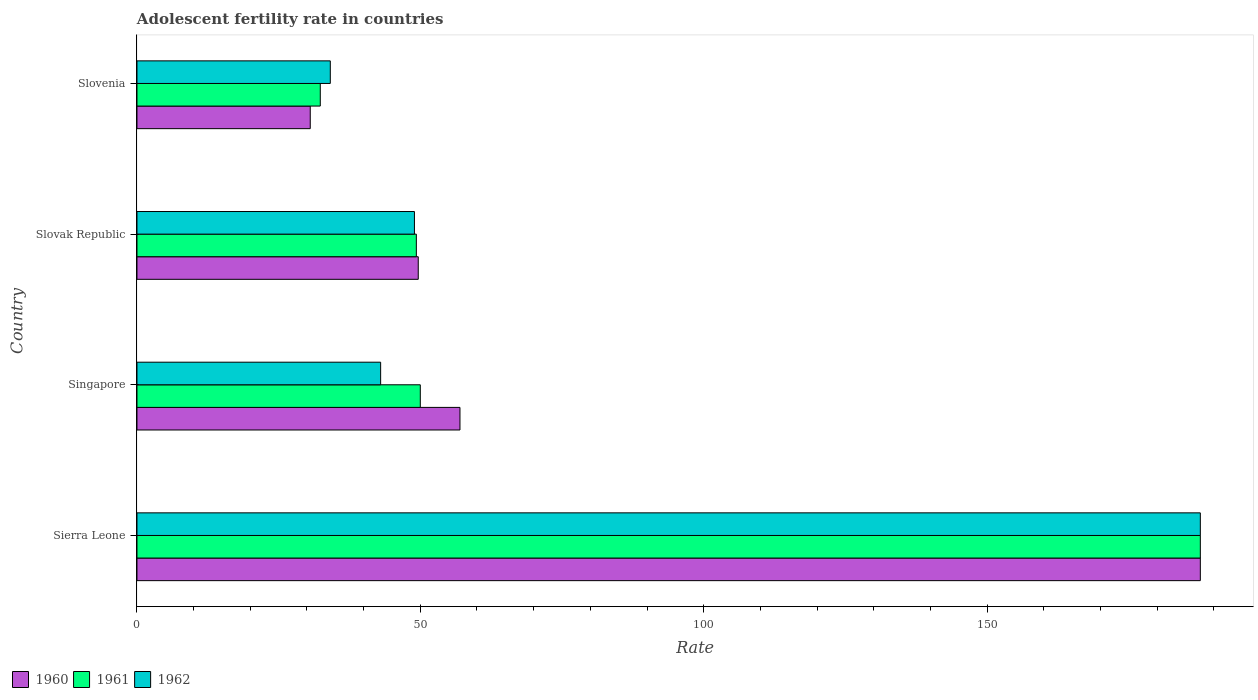How many different coloured bars are there?
Keep it short and to the point. 3. How many groups of bars are there?
Offer a terse response. 4. Are the number of bars per tick equal to the number of legend labels?
Offer a very short reply. Yes. Are the number of bars on each tick of the Y-axis equal?
Your response must be concise. Yes. How many bars are there on the 2nd tick from the top?
Provide a short and direct response. 3. How many bars are there on the 3rd tick from the bottom?
Your response must be concise. 3. What is the label of the 1st group of bars from the top?
Your answer should be compact. Slovenia. In how many cases, is the number of bars for a given country not equal to the number of legend labels?
Your response must be concise. 0. What is the adolescent fertility rate in 1962 in Slovak Republic?
Make the answer very short. 48.96. Across all countries, what is the maximum adolescent fertility rate in 1961?
Make the answer very short. 187.64. Across all countries, what is the minimum adolescent fertility rate in 1961?
Keep it short and to the point. 32.35. In which country was the adolescent fertility rate in 1962 maximum?
Offer a very short reply. Sierra Leone. In which country was the adolescent fertility rate in 1961 minimum?
Provide a short and direct response. Slovenia. What is the total adolescent fertility rate in 1961 in the graph?
Provide a short and direct response. 319.28. What is the difference between the adolescent fertility rate in 1960 in Sierra Leone and that in Slovak Republic?
Provide a short and direct response. 138. What is the difference between the adolescent fertility rate in 1962 in Slovak Republic and the adolescent fertility rate in 1960 in Slovenia?
Offer a very short reply. 18.38. What is the average adolescent fertility rate in 1960 per country?
Keep it short and to the point. 81.21. What is the difference between the adolescent fertility rate in 1962 and adolescent fertility rate in 1960 in Slovenia?
Give a very brief answer. 3.54. In how many countries, is the adolescent fertility rate in 1962 greater than 50 ?
Your answer should be very brief. 1. What is the ratio of the adolescent fertility rate in 1962 in Singapore to that in Slovak Republic?
Make the answer very short. 0.88. Is the adolescent fertility rate in 1961 in Slovak Republic less than that in Slovenia?
Offer a very short reply. No. What is the difference between the highest and the second highest adolescent fertility rate in 1960?
Give a very brief answer. 130.64. What is the difference between the highest and the lowest adolescent fertility rate in 1961?
Offer a very short reply. 155.29. Is the sum of the adolescent fertility rate in 1962 in Singapore and Slovenia greater than the maximum adolescent fertility rate in 1961 across all countries?
Your answer should be compact. No. What does the 3rd bar from the bottom in Slovenia represents?
Make the answer very short. 1962. How many countries are there in the graph?
Ensure brevity in your answer.  4. Are the values on the major ticks of X-axis written in scientific E-notation?
Keep it short and to the point. No. Does the graph contain grids?
Your answer should be very brief. No. Where does the legend appear in the graph?
Your answer should be very brief. Bottom left. What is the title of the graph?
Ensure brevity in your answer.  Adolescent fertility rate in countries. What is the label or title of the X-axis?
Your response must be concise. Rate. What is the label or title of the Y-axis?
Make the answer very short. Country. What is the Rate of 1960 in Sierra Leone?
Your answer should be very brief. 187.64. What is the Rate of 1961 in Sierra Leone?
Give a very brief answer. 187.64. What is the Rate of 1962 in Sierra Leone?
Keep it short and to the point. 187.64. What is the Rate in 1960 in Singapore?
Ensure brevity in your answer.  57. What is the Rate in 1961 in Singapore?
Give a very brief answer. 50. What is the Rate in 1962 in Singapore?
Your answer should be very brief. 43. What is the Rate of 1960 in Slovak Republic?
Ensure brevity in your answer.  49.64. What is the Rate in 1961 in Slovak Republic?
Offer a terse response. 49.3. What is the Rate of 1962 in Slovak Republic?
Offer a terse response. 48.96. What is the Rate of 1960 in Slovenia?
Make the answer very short. 30.58. What is the Rate of 1961 in Slovenia?
Offer a terse response. 32.35. What is the Rate in 1962 in Slovenia?
Provide a succinct answer. 34.12. Across all countries, what is the maximum Rate in 1960?
Make the answer very short. 187.64. Across all countries, what is the maximum Rate of 1961?
Make the answer very short. 187.64. Across all countries, what is the maximum Rate of 1962?
Make the answer very short. 187.64. Across all countries, what is the minimum Rate of 1960?
Offer a terse response. 30.58. Across all countries, what is the minimum Rate of 1961?
Provide a succinct answer. 32.35. Across all countries, what is the minimum Rate of 1962?
Offer a very short reply. 34.12. What is the total Rate in 1960 in the graph?
Offer a terse response. 324.85. What is the total Rate of 1961 in the graph?
Offer a terse response. 319.28. What is the total Rate of 1962 in the graph?
Keep it short and to the point. 313.72. What is the difference between the Rate in 1960 in Sierra Leone and that in Singapore?
Provide a short and direct response. 130.64. What is the difference between the Rate of 1961 in Sierra Leone and that in Singapore?
Keep it short and to the point. 137.64. What is the difference between the Rate of 1962 in Sierra Leone and that in Singapore?
Keep it short and to the point. 144.64. What is the difference between the Rate in 1960 in Sierra Leone and that in Slovak Republic?
Offer a terse response. 138. What is the difference between the Rate in 1961 in Sierra Leone and that in Slovak Republic?
Offer a terse response. 138.34. What is the difference between the Rate in 1962 in Sierra Leone and that in Slovak Republic?
Your response must be concise. 138.68. What is the difference between the Rate of 1960 in Sierra Leone and that in Slovenia?
Provide a short and direct response. 157.06. What is the difference between the Rate of 1961 in Sierra Leone and that in Slovenia?
Ensure brevity in your answer.  155.29. What is the difference between the Rate in 1962 in Sierra Leone and that in Slovenia?
Keep it short and to the point. 153.52. What is the difference between the Rate of 1960 in Singapore and that in Slovak Republic?
Your answer should be compact. 7.36. What is the difference between the Rate of 1961 in Singapore and that in Slovak Republic?
Offer a very short reply. 0.7. What is the difference between the Rate in 1962 in Singapore and that in Slovak Republic?
Your answer should be compact. -5.96. What is the difference between the Rate of 1960 in Singapore and that in Slovenia?
Provide a short and direct response. 26.42. What is the difference between the Rate in 1961 in Singapore and that in Slovenia?
Provide a succinct answer. 17.65. What is the difference between the Rate in 1962 in Singapore and that in Slovenia?
Give a very brief answer. 8.88. What is the difference between the Rate of 1960 in Slovak Republic and that in Slovenia?
Make the answer very short. 19.06. What is the difference between the Rate of 1961 in Slovak Republic and that in Slovenia?
Offer a terse response. 16.95. What is the difference between the Rate of 1962 in Slovak Republic and that in Slovenia?
Your answer should be compact. 14.85. What is the difference between the Rate in 1960 in Sierra Leone and the Rate in 1961 in Singapore?
Your answer should be compact. 137.64. What is the difference between the Rate of 1960 in Sierra Leone and the Rate of 1962 in Singapore?
Provide a succinct answer. 144.64. What is the difference between the Rate of 1961 in Sierra Leone and the Rate of 1962 in Singapore?
Your response must be concise. 144.64. What is the difference between the Rate in 1960 in Sierra Leone and the Rate in 1961 in Slovak Republic?
Keep it short and to the point. 138.34. What is the difference between the Rate in 1960 in Sierra Leone and the Rate in 1962 in Slovak Republic?
Offer a terse response. 138.68. What is the difference between the Rate of 1961 in Sierra Leone and the Rate of 1962 in Slovak Republic?
Ensure brevity in your answer.  138.68. What is the difference between the Rate in 1960 in Sierra Leone and the Rate in 1961 in Slovenia?
Keep it short and to the point. 155.29. What is the difference between the Rate in 1960 in Sierra Leone and the Rate in 1962 in Slovenia?
Provide a succinct answer. 153.52. What is the difference between the Rate of 1961 in Sierra Leone and the Rate of 1962 in Slovenia?
Make the answer very short. 153.52. What is the difference between the Rate of 1960 in Singapore and the Rate of 1961 in Slovak Republic?
Your answer should be compact. 7.7. What is the difference between the Rate in 1960 in Singapore and the Rate in 1962 in Slovak Republic?
Give a very brief answer. 8.03. What is the difference between the Rate of 1961 in Singapore and the Rate of 1962 in Slovak Republic?
Your answer should be compact. 1.03. What is the difference between the Rate in 1960 in Singapore and the Rate in 1961 in Slovenia?
Your answer should be compact. 24.65. What is the difference between the Rate of 1960 in Singapore and the Rate of 1962 in Slovenia?
Give a very brief answer. 22.88. What is the difference between the Rate of 1961 in Singapore and the Rate of 1962 in Slovenia?
Your response must be concise. 15.88. What is the difference between the Rate in 1960 in Slovak Republic and the Rate in 1961 in Slovenia?
Offer a terse response. 17.29. What is the difference between the Rate of 1960 in Slovak Republic and the Rate of 1962 in Slovenia?
Keep it short and to the point. 15.52. What is the difference between the Rate of 1961 in Slovak Republic and the Rate of 1962 in Slovenia?
Offer a very short reply. 15.18. What is the average Rate of 1960 per country?
Make the answer very short. 81.21. What is the average Rate in 1961 per country?
Give a very brief answer. 79.82. What is the average Rate in 1962 per country?
Offer a very short reply. 78.43. What is the difference between the Rate of 1960 and Rate of 1962 in Sierra Leone?
Provide a succinct answer. 0. What is the difference between the Rate of 1961 and Rate of 1962 in Sierra Leone?
Offer a very short reply. 0. What is the difference between the Rate in 1960 and Rate in 1961 in Singapore?
Keep it short and to the point. 7. What is the difference between the Rate in 1960 and Rate in 1962 in Singapore?
Provide a succinct answer. 14. What is the difference between the Rate of 1961 and Rate of 1962 in Singapore?
Make the answer very short. 7. What is the difference between the Rate in 1960 and Rate in 1961 in Slovak Republic?
Offer a terse response. 0.34. What is the difference between the Rate of 1960 and Rate of 1962 in Slovak Republic?
Provide a succinct answer. 0.67. What is the difference between the Rate of 1961 and Rate of 1962 in Slovak Republic?
Offer a very short reply. 0.34. What is the difference between the Rate of 1960 and Rate of 1961 in Slovenia?
Provide a short and direct response. -1.77. What is the difference between the Rate of 1960 and Rate of 1962 in Slovenia?
Offer a very short reply. -3.54. What is the difference between the Rate of 1961 and Rate of 1962 in Slovenia?
Offer a terse response. -1.77. What is the ratio of the Rate of 1960 in Sierra Leone to that in Singapore?
Provide a short and direct response. 3.29. What is the ratio of the Rate in 1961 in Sierra Leone to that in Singapore?
Keep it short and to the point. 3.75. What is the ratio of the Rate in 1962 in Sierra Leone to that in Singapore?
Ensure brevity in your answer.  4.36. What is the ratio of the Rate in 1960 in Sierra Leone to that in Slovak Republic?
Your response must be concise. 3.78. What is the ratio of the Rate of 1961 in Sierra Leone to that in Slovak Republic?
Provide a succinct answer. 3.81. What is the ratio of the Rate of 1962 in Sierra Leone to that in Slovak Republic?
Keep it short and to the point. 3.83. What is the ratio of the Rate of 1960 in Sierra Leone to that in Slovenia?
Give a very brief answer. 6.14. What is the ratio of the Rate in 1961 in Sierra Leone to that in Slovenia?
Your answer should be compact. 5.8. What is the ratio of the Rate in 1960 in Singapore to that in Slovak Republic?
Ensure brevity in your answer.  1.15. What is the ratio of the Rate of 1961 in Singapore to that in Slovak Republic?
Make the answer very short. 1.01. What is the ratio of the Rate of 1962 in Singapore to that in Slovak Republic?
Make the answer very short. 0.88. What is the ratio of the Rate of 1960 in Singapore to that in Slovenia?
Keep it short and to the point. 1.86. What is the ratio of the Rate in 1961 in Singapore to that in Slovenia?
Make the answer very short. 1.55. What is the ratio of the Rate of 1962 in Singapore to that in Slovenia?
Your answer should be very brief. 1.26. What is the ratio of the Rate of 1960 in Slovak Republic to that in Slovenia?
Keep it short and to the point. 1.62. What is the ratio of the Rate in 1961 in Slovak Republic to that in Slovenia?
Offer a very short reply. 1.52. What is the ratio of the Rate of 1962 in Slovak Republic to that in Slovenia?
Keep it short and to the point. 1.44. What is the difference between the highest and the second highest Rate of 1960?
Provide a succinct answer. 130.64. What is the difference between the highest and the second highest Rate of 1961?
Your response must be concise. 137.64. What is the difference between the highest and the second highest Rate of 1962?
Make the answer very short. 138.68. What is the difference between the highest and the lowest Rate of 1960?
Offer a very short reply. 157.06. What is the difference between the highest and the lowest Rate in 1961?
Your answer should be very brief. 155.29. What is the difference between the highest and the lowest Rate in 1962?
Your answer should be compact. 153.52. 